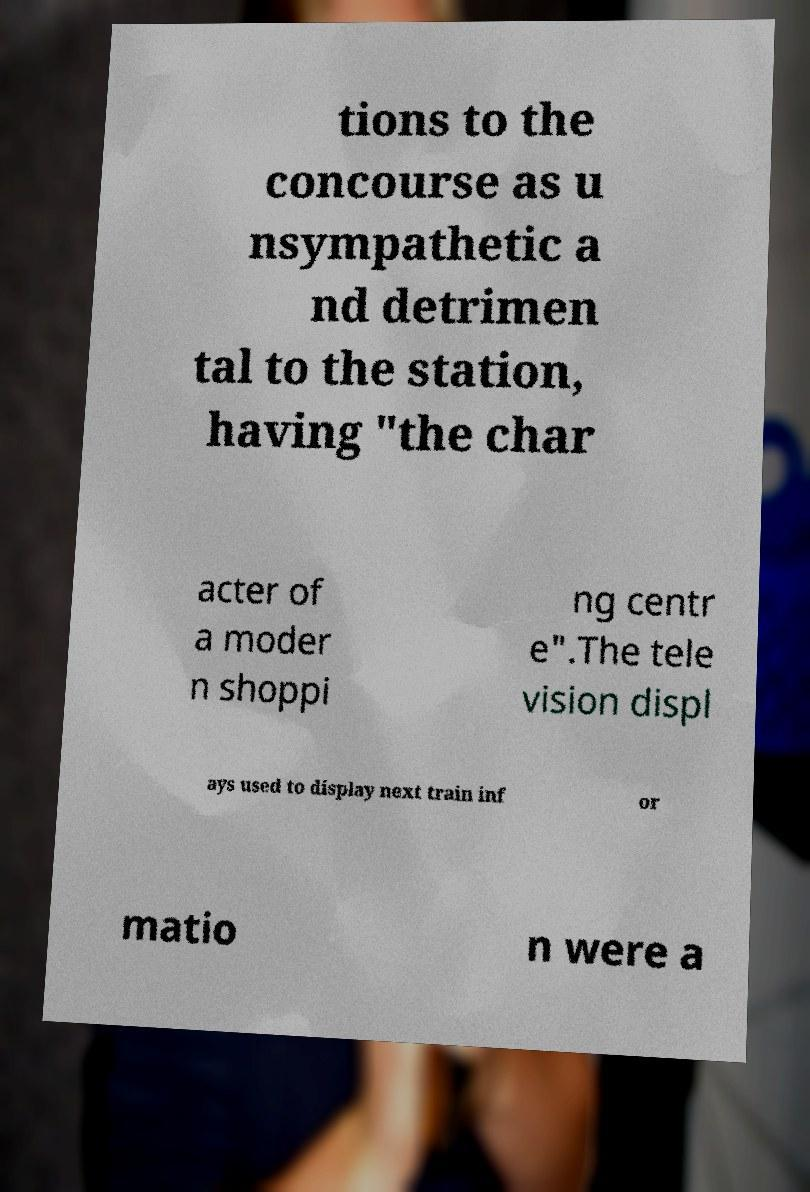I need the written content from this picture converted into text. Can you do that? tions to the concourse as u nsympathetic a nd detrimen tal to the station, having "the char acter of a moder n shoppi ng centr e".The tele vision displ ays used to display next train inf or matio n were a 